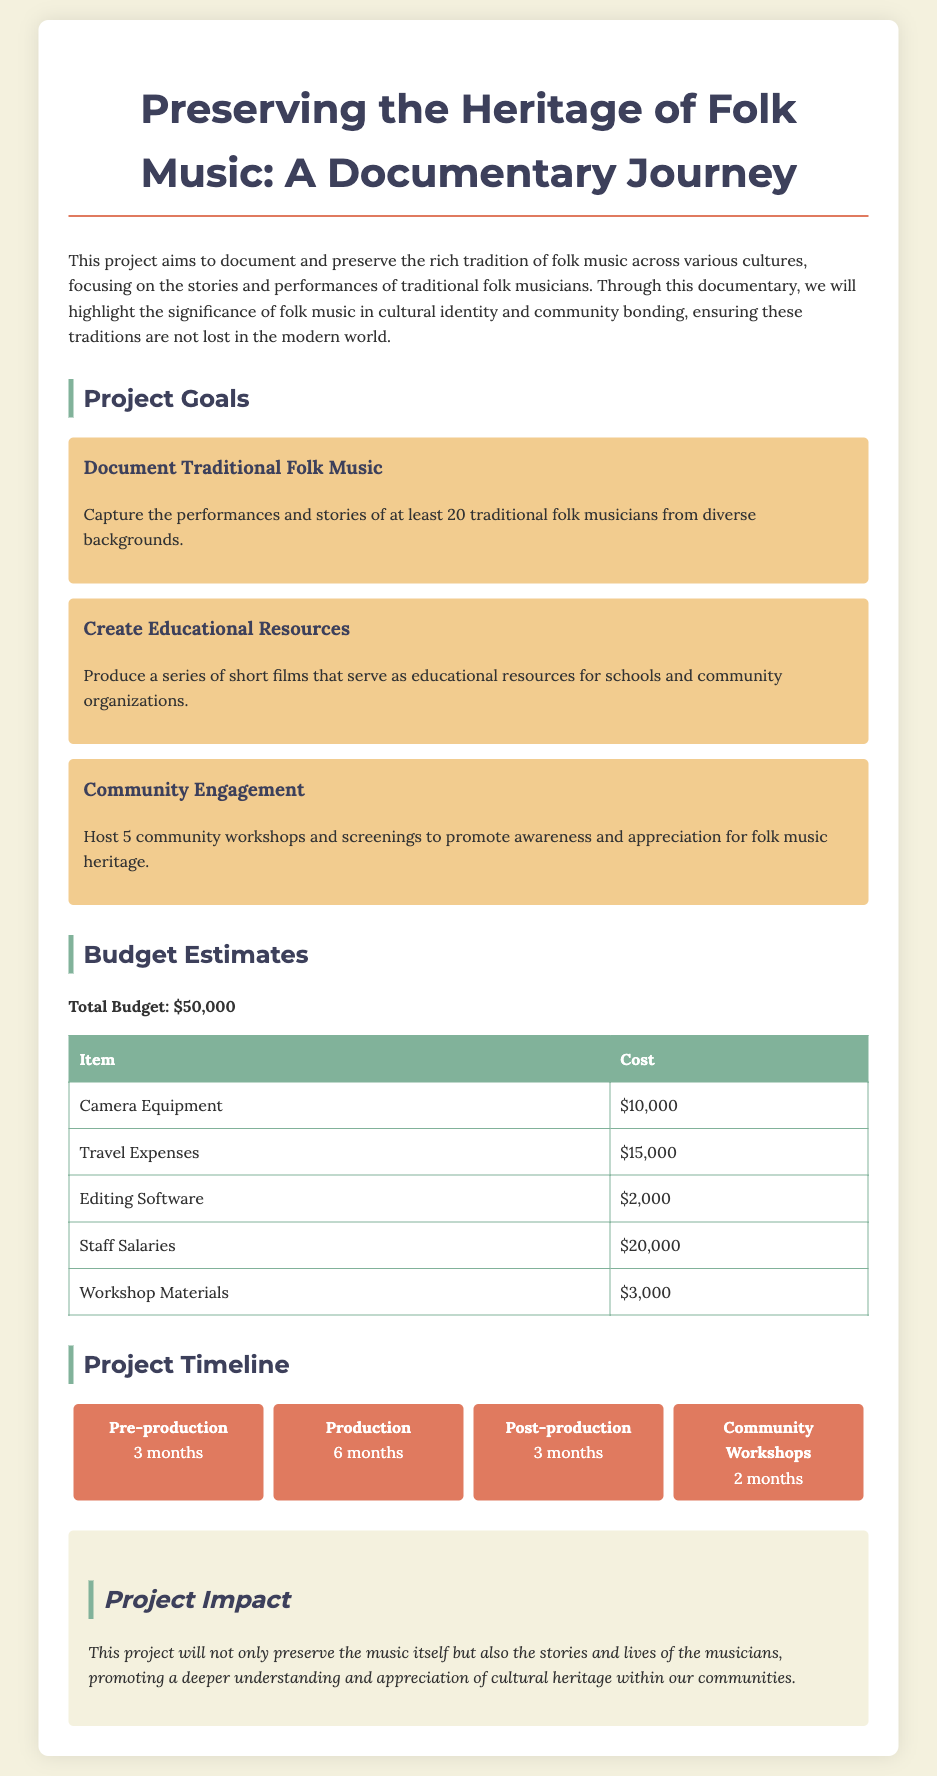What is the total budget for the project? The total budget is specified in the document as $50,000.
Answer: $50,000 How many traditional folk musicians will be documented? The document states that the project aims to capture the performances and stories of at least 20 traditional folk musicians.
Answer: 20 What is the budget for Camera Equipment? The cost for Camera Equipment is detailed in the budget table as $10,000.
Answer: $10,000 What is the duration of the production phase? The timeline indicates that the production phase will last for 6 months.
Answer: 6 months What is one of the goals related to educational resources? One of the project goals is to produce short films that serve as educational resources for schools and community organizations.
Answer: Produce educational short films What are the community engagement activities planned? The document outlines that 5 community workshops and screenings will be hosted to promote folk music heritage.
Answer: 5 workshops What is the total cost for staff salaries? The total cost allocated for staff salaries is specified as $20,000.
Answer: $20,000 What month is designated for post-production? The project timeline mentions post-production as lasting for 3 months, which follows the production phase.
Answer: 3 months Which item has the highest cost in the budget? The highest cost item in the budget is staff salaries at $20,000.
Answer: Staff salaries 